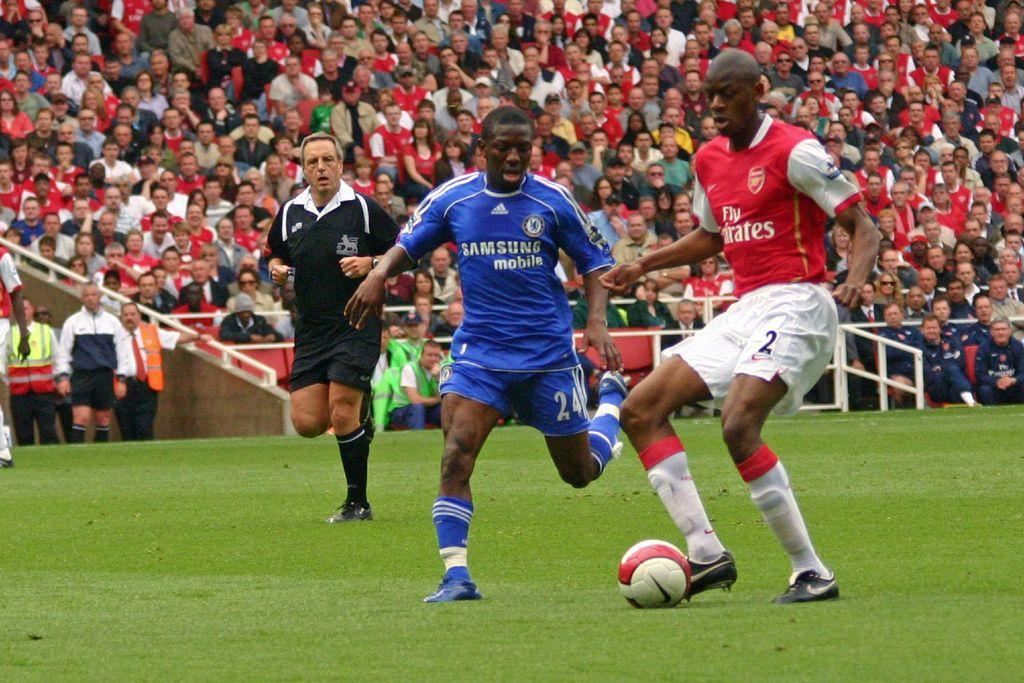<image>
Summarize the visual content of the image. Soccer players on the field that are sposored by Samsung Mobile # 24 and Fly Emirates # 2. 